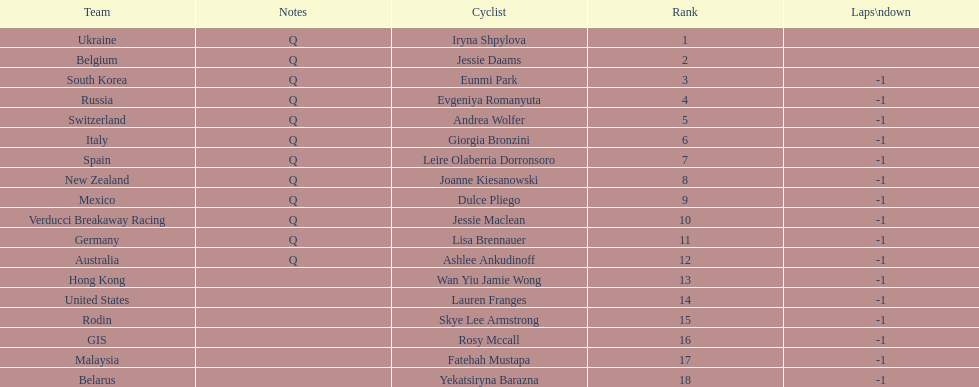Who was the first competitor to finish the race a lap behind? Eunmi Park. 